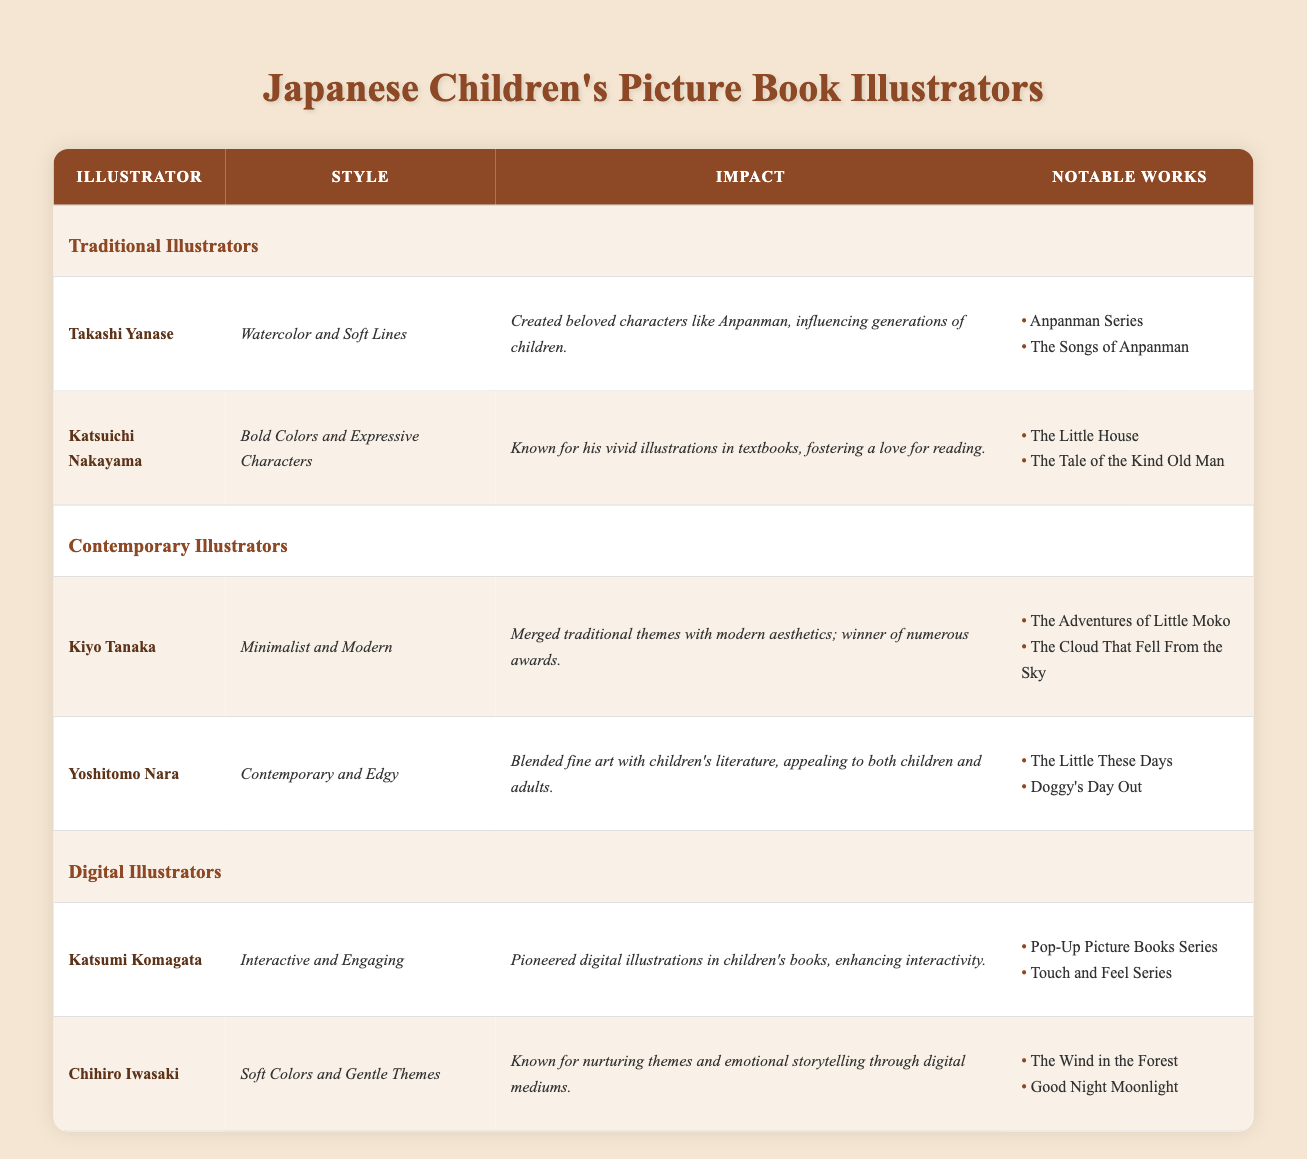What is the illustration style of Takashi Yanase? Takashi Yanase's style is listed in the table as "Watercolor and Soft Lines".
Answer: Watercolor and Soft Lines Which illustrator is known for bold colors and expressive characters? The table shows that Katsuichi Nakayama is known for “Bold Colors and Expressive Characters.”
Answer: Katsuichi Nakayama How many notable works does Kiyo Tanaka have listed in the table? Kiyo Tanaka has two notable works listed in the table: "The Adventures of Little Moko" and "The Cloud That Fell From the Sky."
Answer: 2 Is it true that Yoshitomo Nara's impact includes appealing to both children and adults? The impact section for Yoshitomo Nara confirms that he blended fine art with children’s literature, which appeals to both children and adults.
Answer: Yes Which group does Chihiro Iwasaki belong to, Traditional, Contemporary, or Digital Illustrators? The table categorizes Chihiro Iwasaki under the group of Digital Illustrators.
Answer: Digital Illustrators What is the primary impact of Katsumi Komagata's illustrations? The table states that Katsumi Komagata pioneered digital illustrations in children's books, enhancing interactivity, which is highlighted in the impact section.
Answer: Pioneered digital illustrations If we consider the styles of traditional illustrators only, how many distinct styles are represented in the table? The table shows two traditional illustrators with distinct styles: Takashi Yanase's "Watercolor and Soft Lines" and Katsuichi Nakayama's "Bold Colors and Expressive Characters," so there are 2 distinct styles.
Answer: 2 Which illustrator has notably contributed to emotional storytelling through digital mediums? The table indicates that Chihiro Iwasaki is known for nurturing themes and emotional storytelling through digital mediums.
Answer: Chihiro Iwasaki List the notable works of Katsumi Komagata. According to the table, Katsumi Komagata's notable works include "Pop-Up Picture Books Series" and "Touch and Feel Series."
Answer: Pop-Up Picture Books Series, Touch and Feel Series 